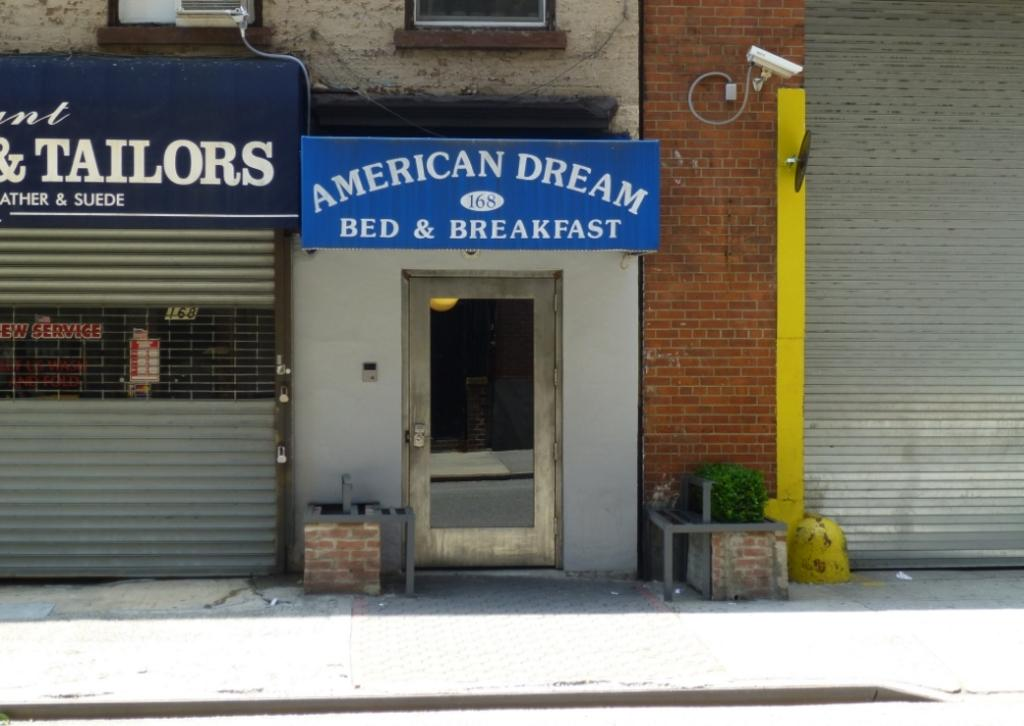What can be seen on the left side of the image? There is a shutter on the left side of the image. What is the main subject in the middle of the image? There is a store in the middle of the image. What security feature is present in the image? There is a CCTV camera on the wall. What type of vegetation is at the bottom of the image? There is a plant at the bottom of the image. Can you tell me how many volleyballs are on the roof of the store in the image? There are no volleyballs present in the image; it only features a shutter, a store, a CCTV camera, and a plant. What type of branch is supporting the CCTV camera in the image? There is no branch present in the image; the CCTV camera is mounted on the wall. 